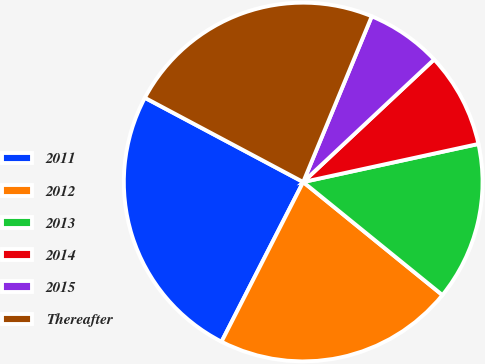Convert chart to OTSL. <chart><loc_0><loc_0><loc_500><loc_500><pie_chart><fcel>2011<fcel>2012<fcel>2013<fcel>2014<fcel>2015<fcel>Thereafter<nl><fcel>25.26%<fcel>21.67%<fcel>14.26%<fcel>8.57%<fcel>6.78%<fcel>23.46%<nl></chart> 